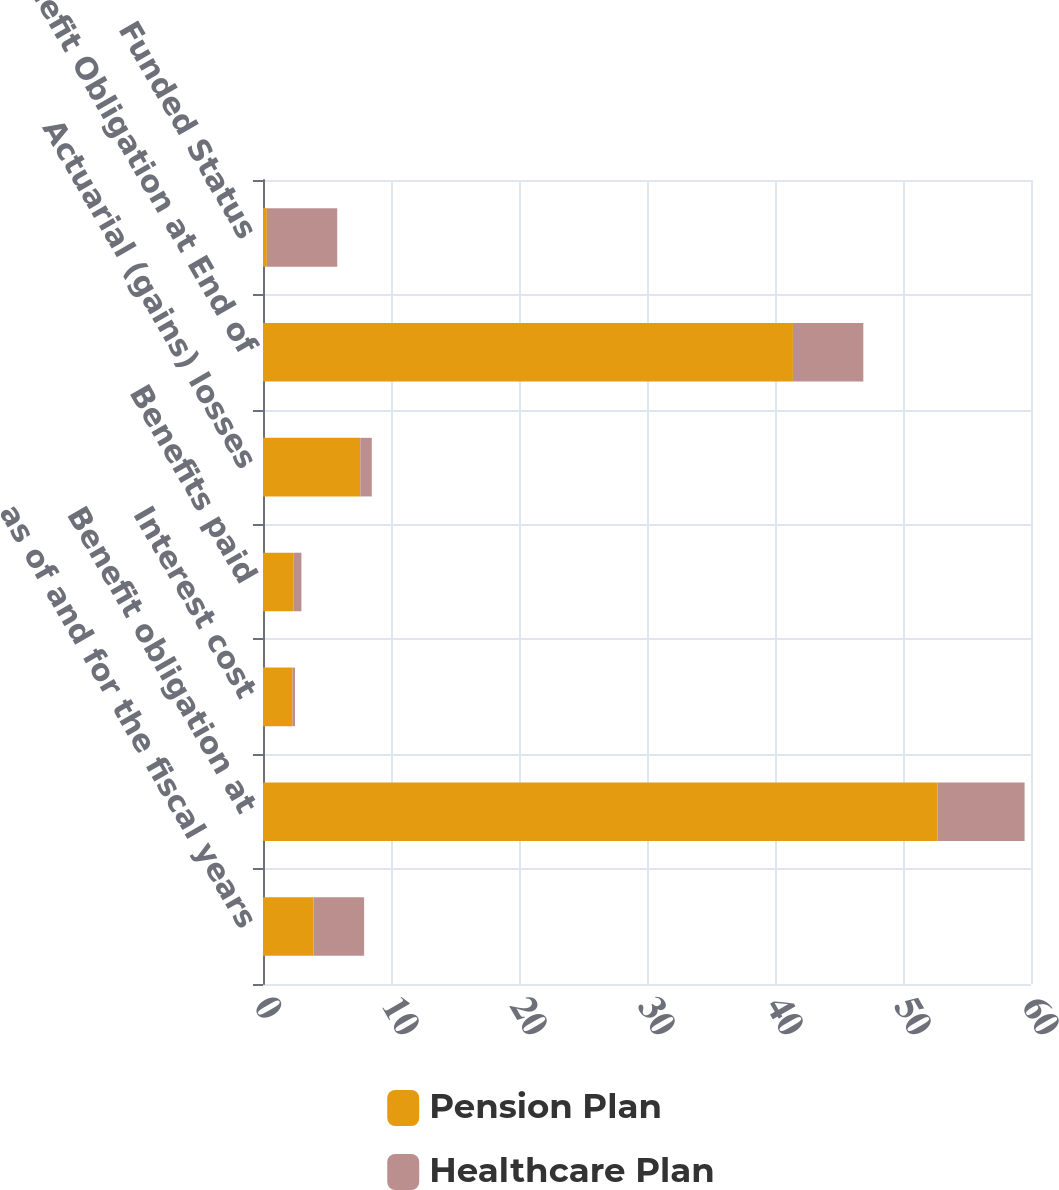Convert chart. <chart><loc_0><loc_0><loc_500><loc_500><stacked_bar_chart><ecel><fcel>as of and for the fiscal years<fcel>Benefit obligation at<fcel>Interest cost<fcel>Benefits paid<fcel>Actuarial (gains) losses<fcel>Benefit Obligation at End of<fcel>Funded Status<nl><fcel>Pension Plan<fcel>3.95<fcel>52.7<fcel>2.3<fcel>2.4<fcel>7.6<fcel>41.4<fcel>0.3<nl><fcel>Healthcare Plan<fcel>3.95<fcel>6.8<fcel>0.2<fcel>0.6<fcel>0.9<fcel>5.5<fcel>5.5<nl></chart> 